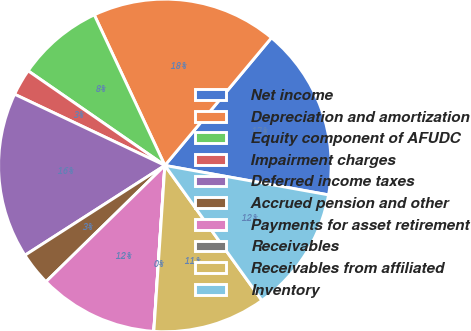Convert chart. <chart><loc_0><loc_0><loc_500><loc_500><pie_chart><fcel>Net income<fcel>Depreciation and amortization<fcel>Equity component of AFUDC<fcel>Impairment charges<fcel>Deferred income taxes<fcel>Accrued pension and other<fcel>Payments for asset retirement<fcel>Receivables<fcel>Receivables from affiliated<fcel>Inventory<nl><fcel>16.76%<fcel>18.05%<fcel>8.39%<fcel>2.59%<fcel>16.12%<fcel>3.24%<fcel>11.61%<fcel>0.01%<fcel>10.97%<fcel>12.25%<nl></chart> 